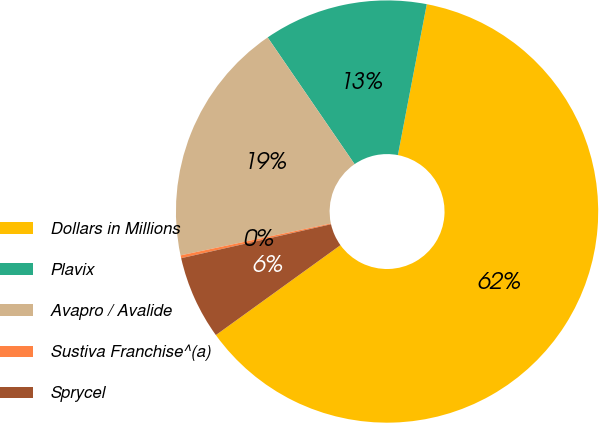Convert chart. <chart><loc_0><loc_0><loc_500><loc_500><pie_chart><fcel>Dollars in Millions<fcel>Plavix<fcel>Avapro / Avalide<fcel>Sustiva Franchise^(a)<fcel>Sprycel<nl><fcel>62.04%<fcel>12.58%<fcel>18.76%<fcel>0.22%<fcel>6.4%<nl></chart> 